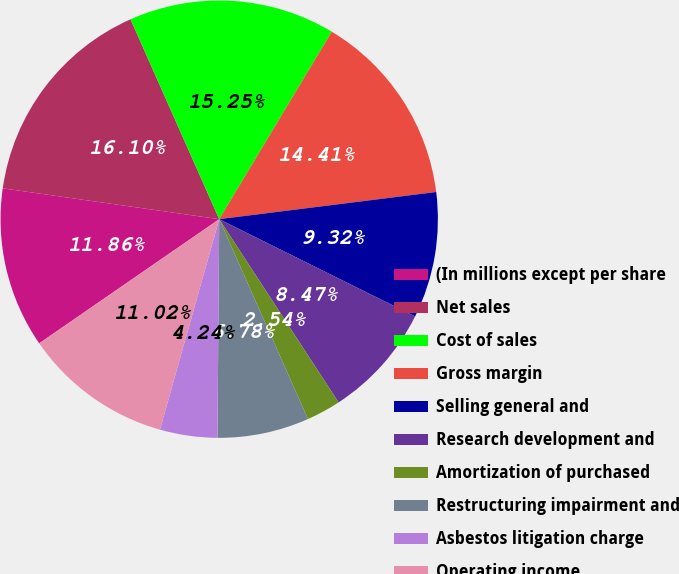Convert chart to OTSL. <chart><loc_0><loc_0><loc_500><loc_500><pie_chart><fcel>(In millions except per share<fcel>Net sales<fcel>Cost of sales<fcel>Gross margin<fcel>Selling general and<fcel>Research development and<fcel>Amortization of purchased<fcel>Restructuring impairment and<fcel>Asbestos litigation charge<fcel>Operating income<nl><fcel>11.86%<fcel>16.1%<fcel>15.25%<fcel>14.41%<fcel>9.32%<fcel>8.47%<fcel>2.54%<fcel>6.78%<fcel>4.24%<fcel>11.02%<nl></chart> 